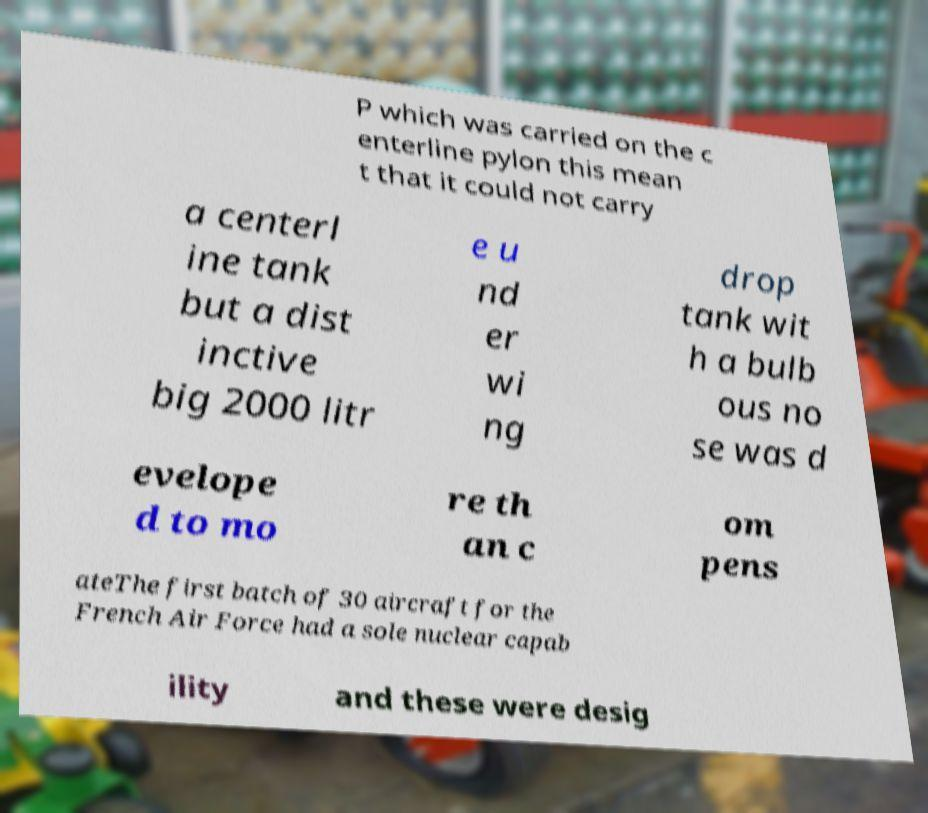For documentation purposes, I need the text within this image transcribed. Could you provide that? P which was carried on the c enterline pylon this mean t that it could not carry a centerl ine tank but a dist inctive big 2000 litr e u nd er wi ng drop tank wit h a bulb ous no se was d evelope d to mo re th an c om pens ateThe first batch of 30 aircraft for the French Air Force had a sole nuclear capab ility and these were desig 